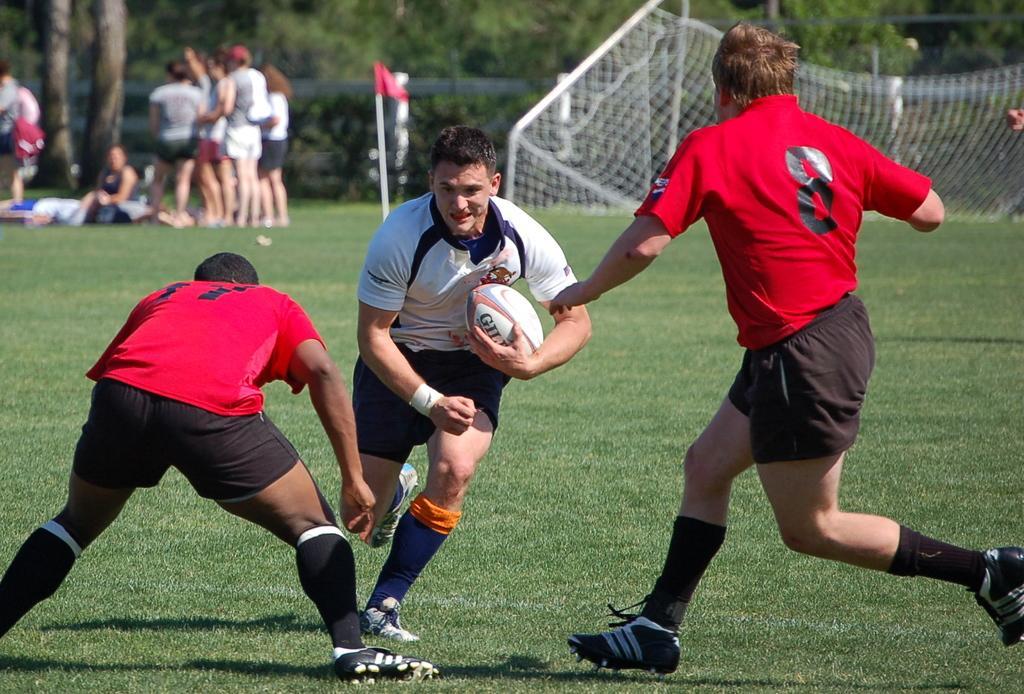Describe this image in one or two sentences. In this image I can see few people and here I can see a man is holding a ball. In the background I can see few more people are standing and here I can see a flag and a tree. 